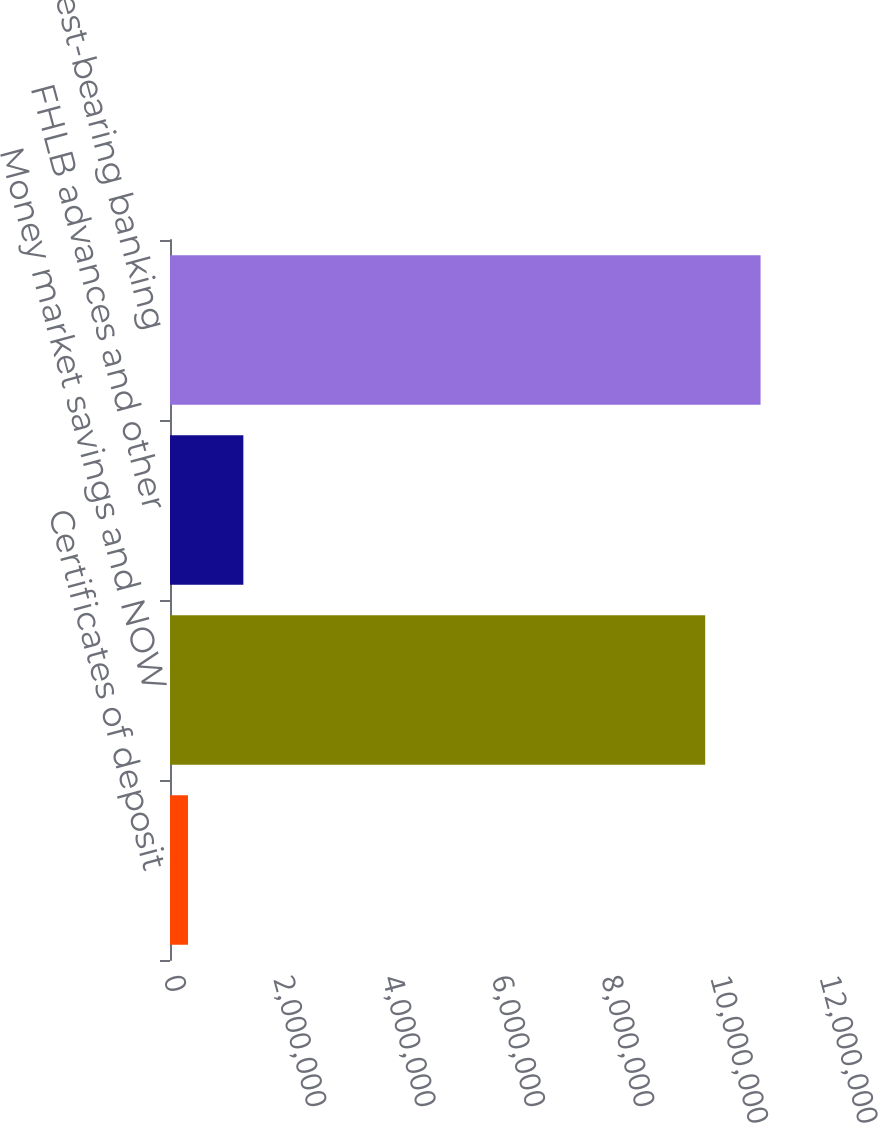Convert chart to OTSL. <chart><loc_0><loc_0><loc_500><loc_500><bar_chart><fcel>Certificates of deposit<fcel>Money market savings and NOW<fcel>FHLB advances and other<fcel>Total interest-bearing banking<nl><fcel>329176<fcel>9.79026e+06<fcel>1.34196e+06<fcel>1.0803e+07<nl></chart> 